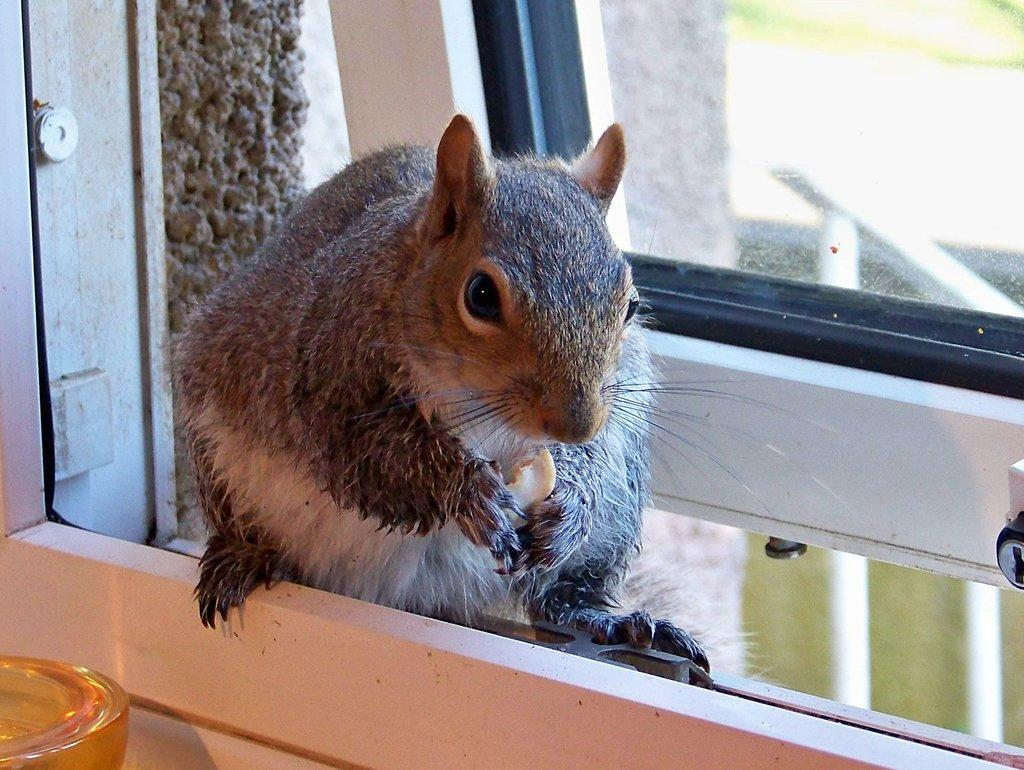What is the main subject in the center of the image? There is a squirrel in the center of the image. What can be seen behind the squirrel? There is a window behind the squirrel. Where is the box located in the image? The box is in the bottom left side of the image. What type of fuel is the squirrel using to power its movements in the image? The squirrel is not using any fuel to power its movements in the image; it is a still image. 